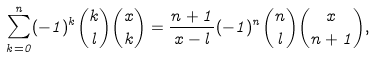Convert formula to latex. <formula><loc_0><loc_0><loc_500><loc_500>\sum _ { k = 0 } ^ { n } ( - 1 ) ^ { k } \binom { k } { l } \binom { x } { k } = \frac { n + 1 } { x - l } ( - 1 ) ^ { n } \binom { n } { l } \binom { x } { n + 1 } ,</formula> 